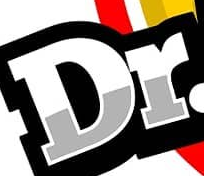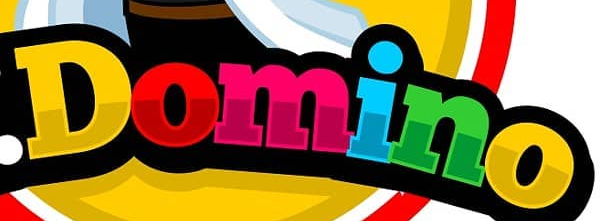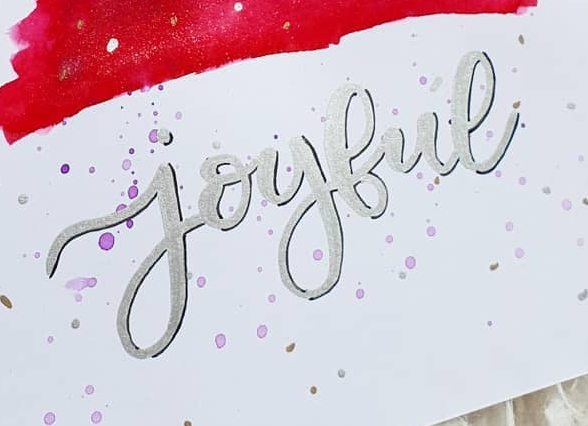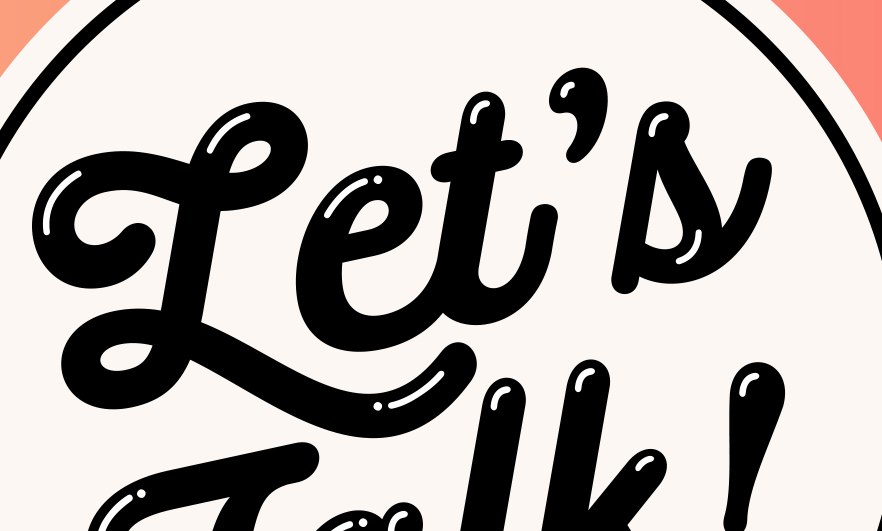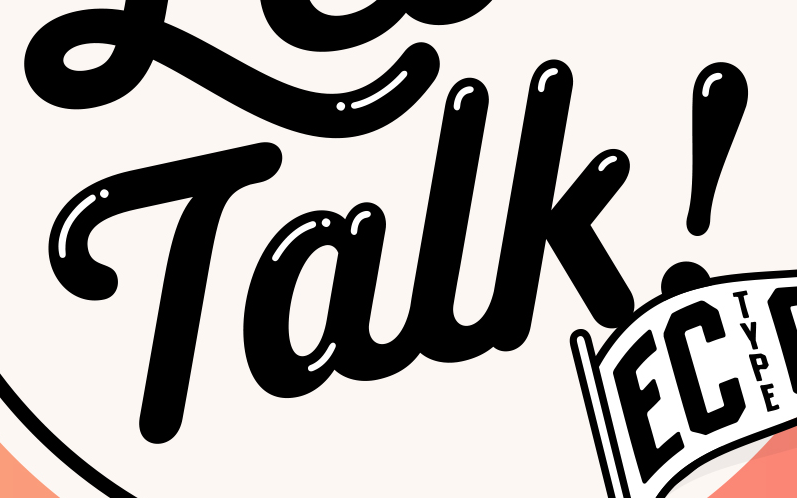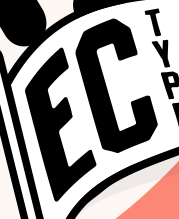Identify the words shown in these images in order, separated by a semicolon. Dr; Domino; joybue; Let's; Talk!; EC 